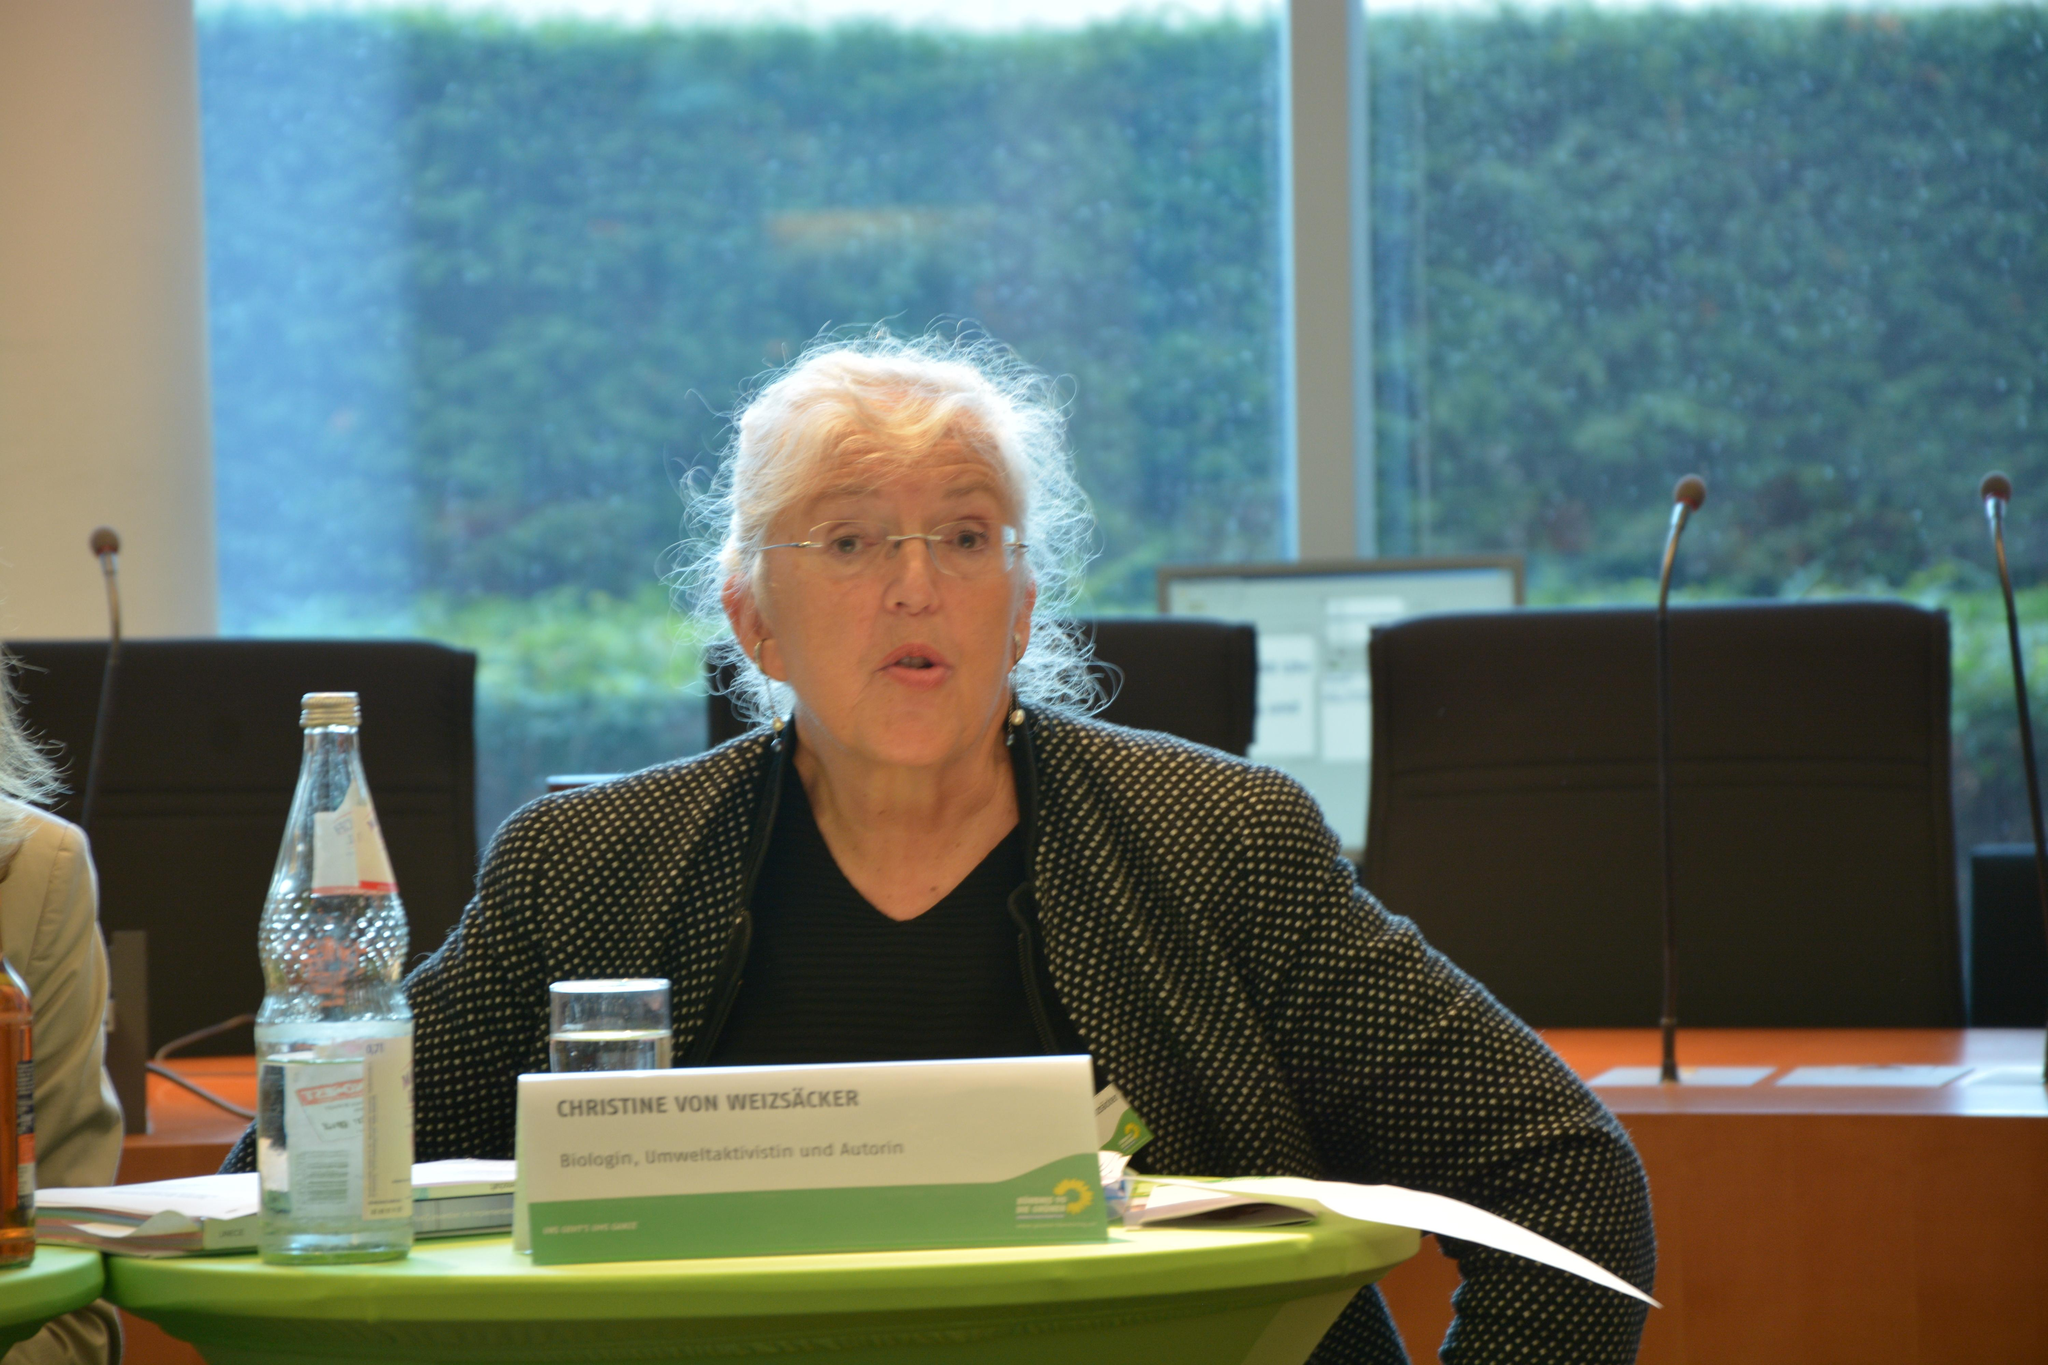What is the woman in the image doing? The woman is sitting on a chair in the image. What objects are visible near the woman? There is a bottle and a glass visible near the woman. What can be seen in the background of the image? There are additional chairs, microphones (mics), and a table in the background of the image. What type of blade is being used by the woman in the image? There is no blade present in the image; the woman is simply sitting on a chair. 